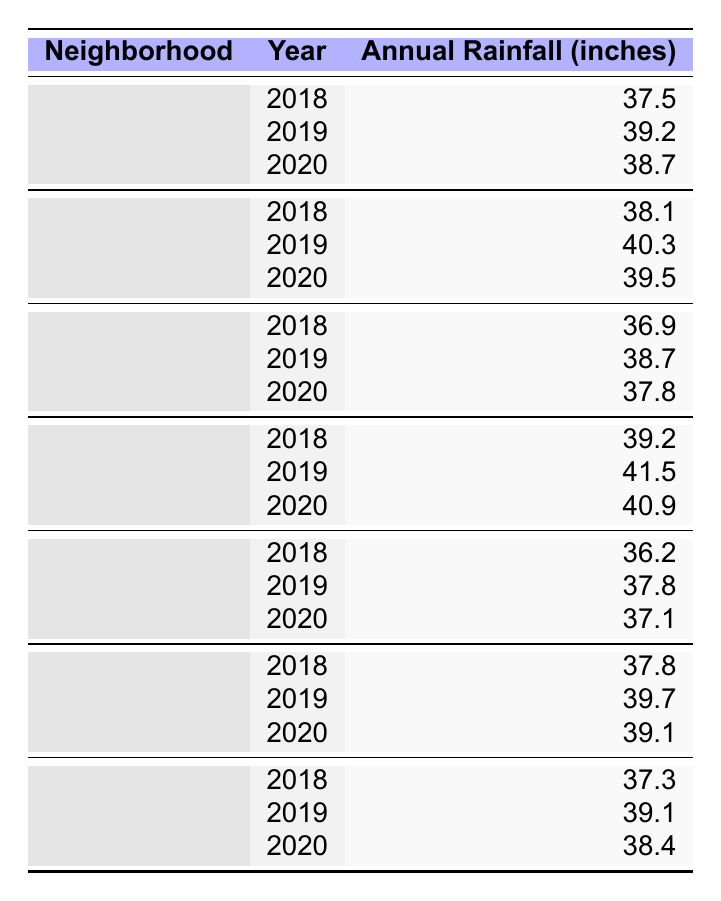What is the annual rainfall for Ballard in 2019? The table shows that the annual rainfall for Ballard in 2019 is indicated directly in the row for that year. It states 39.2 inches.
Answer: 39.2 inches Which neighborhood had the highest annual rainfall in 2020? For 2020, we need to compare the annual rainfall values across all neighborhoods. Looking at the table, the annual rainfall for Rainier Valley is 40.9 inches, which is the highest among all listed.
Answer: Rainier Valley What was the minimum annual rainfall recorded in 2018? To find the minimum rainfall for 2018, we look at the rainfall data for each neighborhood for that year. The values are: Ballard 37.5, Capitol Hill 38.1, Queen Anne 36.9, Rainier Valley 39.2, Magnolia 36.2, West Seattle 37.8, and Fremont 37.3. The smallest value is 36.2 inches from Magnolia.
Answer: 36.2 inches What is the average annual rainfall for Capitol Hill over the three years? To find the average for Capitol Hill, we sum the rainfall values for 2018, 2019, and 2020: 38.1 + 40.3 + 39.5 = 117.9 inches. Then, divide by the number of years, which is 3: 117.9 / 3 = 39.3 inches.
Answer: 39.3 inches Did any neighborhood experience a decrease in annual rainfall from 2018 to 2020? We need to check the rainfall values for each neighborhood for both years. For Ballard, the values are 37.5 (2018) and 38.7 (2020), an increase. Capitol Hill shows 38.1 to 39.5, also an increase. For Queen Anne: 36.9 to 37.8, an increase. Rainier Valley: 39.2 to 40.9, an increase. Magnolia: 36.2 to 37.1, an increase. West Seattle: 37.8 to 39.1, an increase. Fremont: 37.3 to 38.4, an increase. Therefore, no neighborhood had a decrease.
Answer: No 